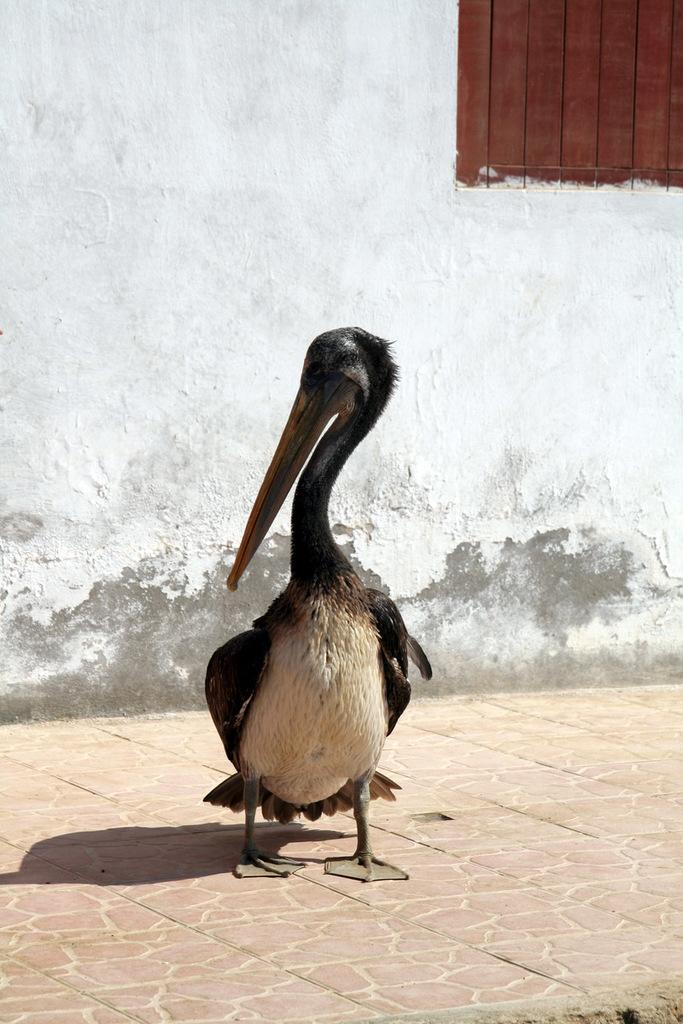How would you summarize this image in a sentence or two? Here there is a bird, here there is wall with the window. 